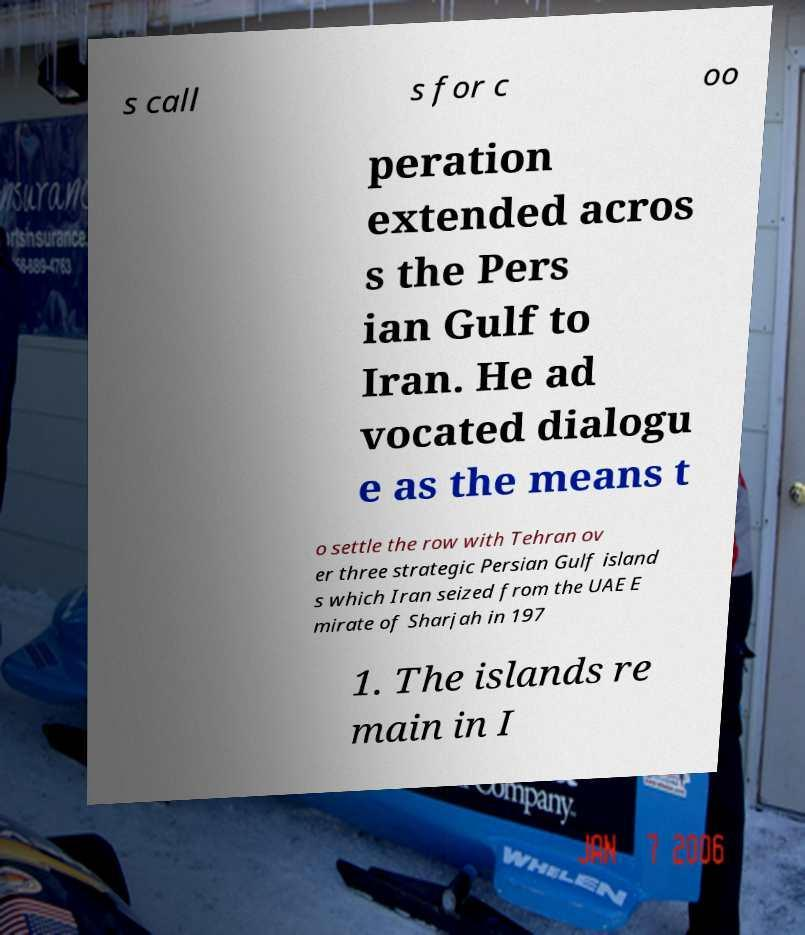For documentation purposes, I need the text within this image transcribed. Could you provide that? s call s for c oo peration extended acros s the Pers ian Gulf to Iran. He ad vocated dialogu e as the means t o settle the row with Tehran ov er three strategic Persian Gulf island s which Iran seized from the UAE E mirate of Sharjah in 197 1. The islands re main in I 